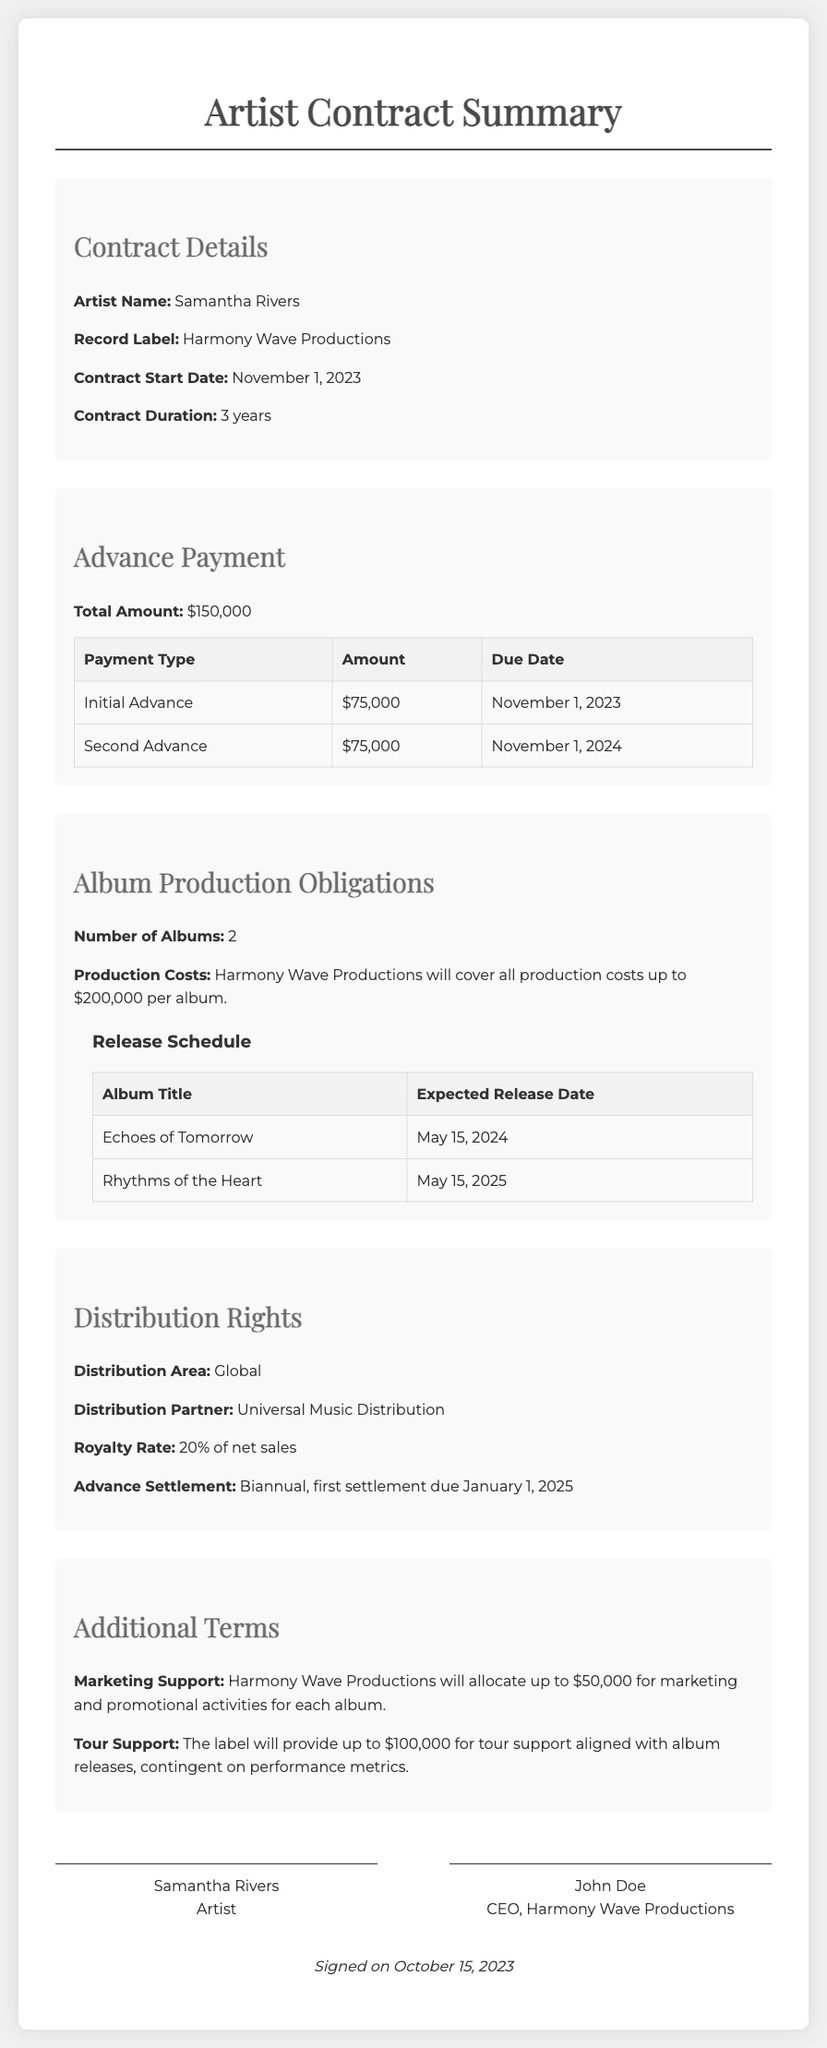what is the artist's name? The artist's name is specified at the beginning of the document under the contract details section.
Answer: Samantha Rivers what is the total advance payment amount? The total advance payment amount is provided in the advance payment section of the document.
Answer: $150,000 how many albums is the artist required to produce? The number of albums is outlined in the album production obligations section.
Answer: 2 when is the first album expected to be released? The expected release date for the first album can be found in the release schedule portion of the document.
Answer: May 15, 2024 who is the distribution partner? The distribution partner is mentioned in the distribution rights section.
Answer: Universal Music Distribution what percentage of net sales will the royalties be? The royalty rate is clearly stated in the distribution rights area of the document.
Answer: 20% what is the total marketing support allocated for each album? The marketing support amount is listed under the additional terms section.
Answer: $50,000 when is the second advance payment due? The due date for the second advance payment is found in the advance payment table.
Answer: November 1, 2024 what is the tour support amount provided by the label? The tour support amount is specified in the additional terms section of the document.
Answer: $100,000 